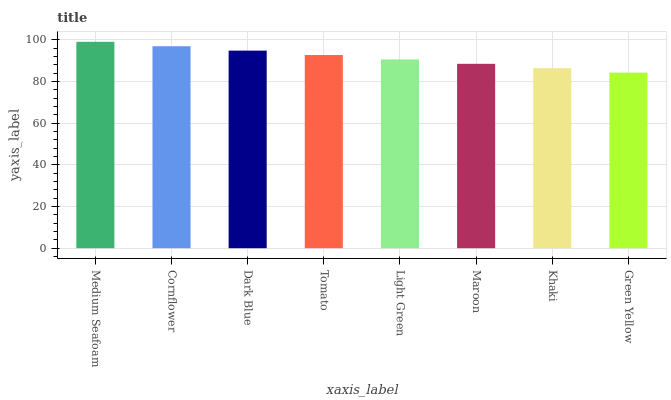Is Cornflower the minimum?
Answer yes or no. No. Is Cornflower the maximum?
Answer yes or no. No. Is Medium Seafoam greater than Cornflower?
Answer yes or no. Yes. Is Cornflower less than Medium Seafoam?
Answer yes or no. Yes. Is Cornflower greater than Medium Seafoam?
Answer yes or no. No. Is Medium Seafoam less than Cornflower?
Answer yes or no. No. Is Tomato the high median?
Answer yes or no. Yes. Is Light Green the low median?
Answer yes or no. Yes. Is Cornflower the high median?
Answer yes or no. No. Is Green Yellow the low median?
Answer yes or no. No. 